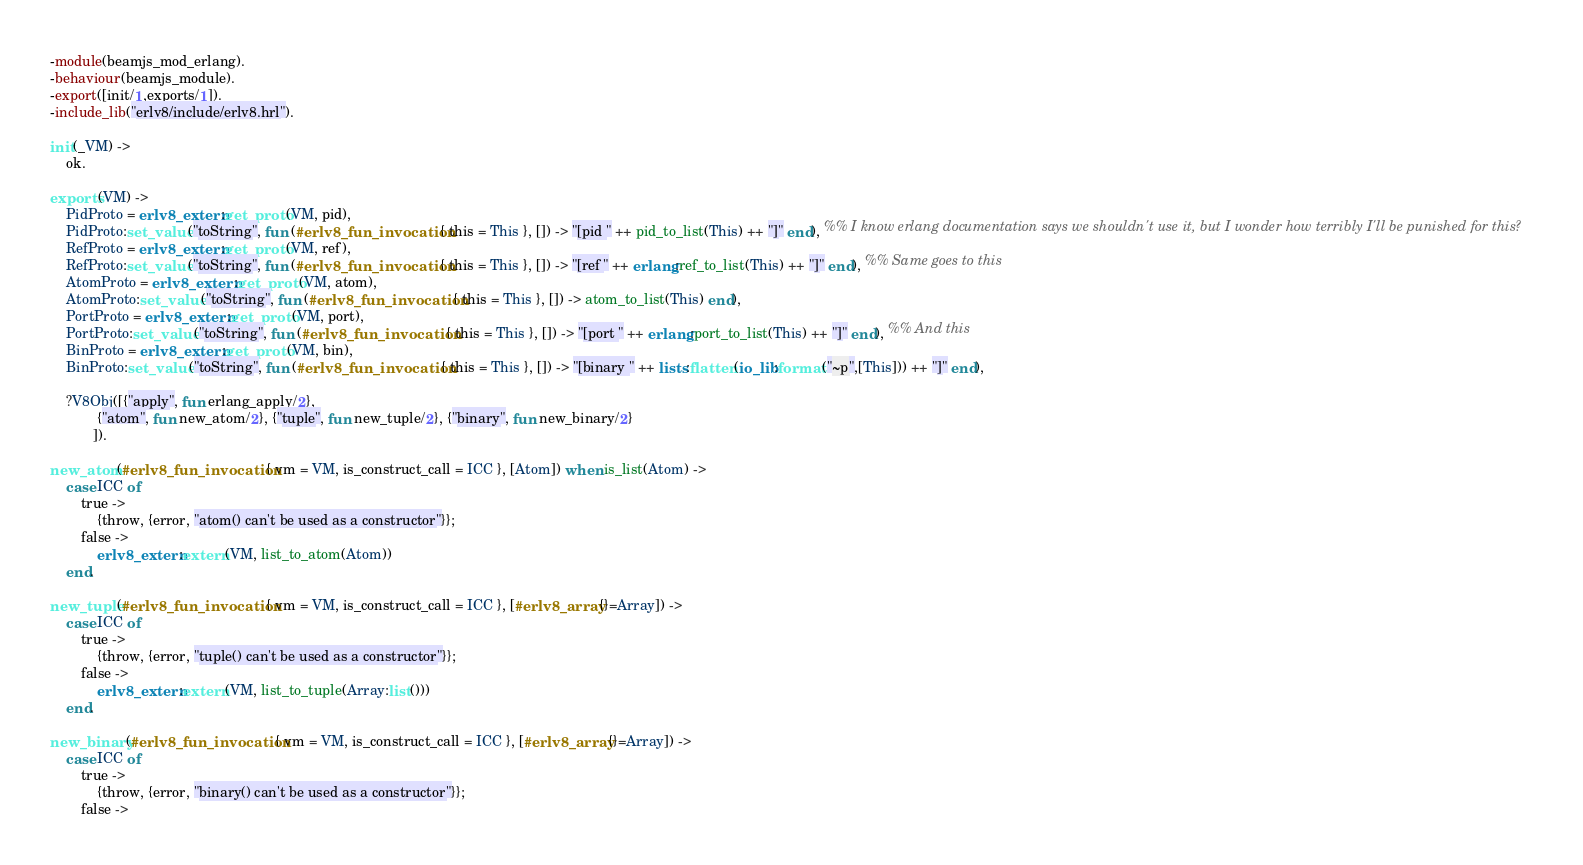<code> <loc_0><loc_0><loc_500><loc_500><_Erlang_>-module(beamjs_mod_erlang).
-behaviour(beamjs_module).
-export([init/1,exports/1]).
-include_lib("erlv8/include/erlv8.hrl").

init(_VM) ->
	ok.

exports(VM) ->
	PidProto = erlv8_extern:get_proto(VM, pid),
	PidProto:set_value("toString", fun (#erlv8_fun_invocation{ this = This }, []) -> "[pid " ++ pid_to_list(This) ++ "]" end), %% I know erlang documentation says we shouldn't use it, but I wonder how terribly I'll be punished for this?
	RefProto = erlv8_extern:get_proto(VM, ref),
	RefProto:set_value("toString", fun (#erlv8_fun_invocation{ this = This }, []) -> "[ref " ++ erlang:ref_to_list(This) ++ "]" end), %% Same goes to this
	AtomProto = erlv8_extern:get_proto(VM, atom),
	AtomProto:set_value("toString", fun (#erlv8_fun_invocation{ this = This }, []) -> atom_to_list(This) end),
	PortProto = erlv8_extern:get_proto(VM, port),
	PortProto:set_value("toString", fun (#erlv8_fun_invocation{ this = This }, []) -> "[port " ++ erlang:port_to_list(This) ++ "]" end), %% And this
	BinProto = erlv8_extern:get_proto(VM, bin),
	BinProto:set_value("toString", fun (#erlv8_fun_invocation{ this = This }, []) -> "[binary " ++ lists:flatten(io_lib:format("~p",[This])) ++ "]" end),

	?V8Obj([{"apply", fun erlang_apply/2},
			{"atom", fun new_atom/2}, {"tuple", fun new_tuple/2}, {"binary", fun new_binary/2}
		   ]).

new_atom(#erlv8_fun_invocation{ vm = VM, is_construct_call = ICC }, [Atom]) when is_list(Atom) ->
	case ICC of
		true ->
			{throw, {error, "atom() can't be used as a constructor"}};
		false ->
			erlv8_extern:extern(VM, list_to_atom(Atom))
	end.

new_tuple(#erlv8_fun_invocation{ vm = VM, is_construct_call = ICC }, [#erlv8_array{}=Array]) ->
	case ICC of
		true ->
			{throw, {error, "tuple() can't be used as a constructor"}};
		false ->
			erlv8_extern:extern(VM, list_to_tuple(Array:list()))
	end.

new_binary(#erlv8_fun_invocation{ vm = VM, is_construct_call = ICC }, [#erlv8_array{}=Array]) ->
	case ICC of
		true ->
			{throw, {error, "binary() can't be used as a constructor"}};
		false -></code> 